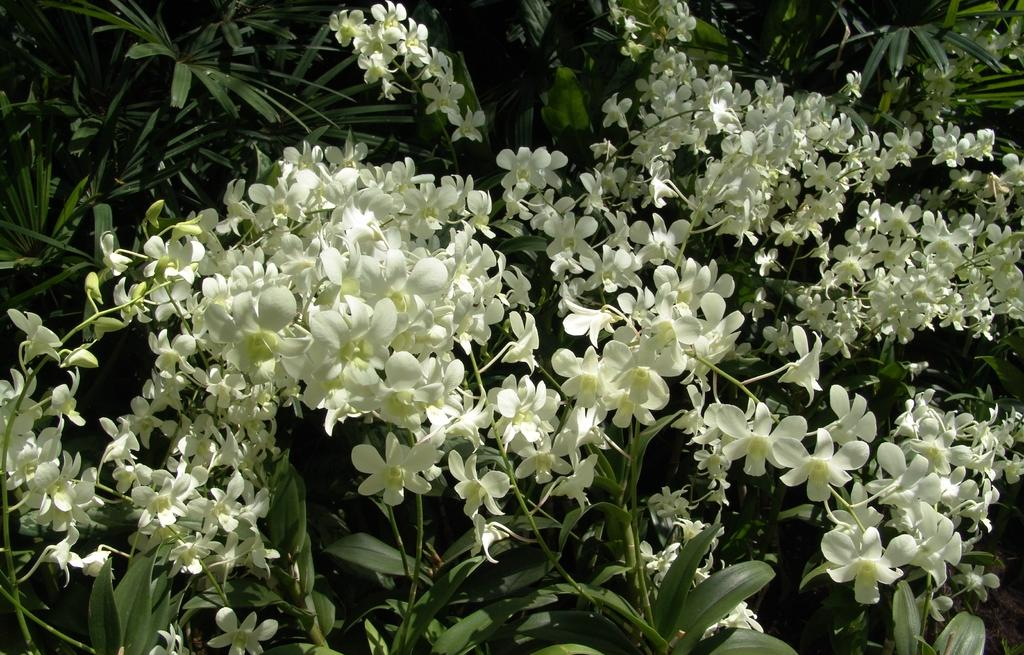What type of flowers can be seen on the plant in the image? There are white color flowers on a plant in the image. Can you describe the color of the flowers? The flowers are white in color. What is the main subject of the image? The main subject of the image is a plant with white flowers. What nation does the queen rule over in the image? There is no queen or nation present in the image; it features a plant with white flowers. Is there a crook visible in the image? There is no crook or any indication of a crook-related object in the image. 